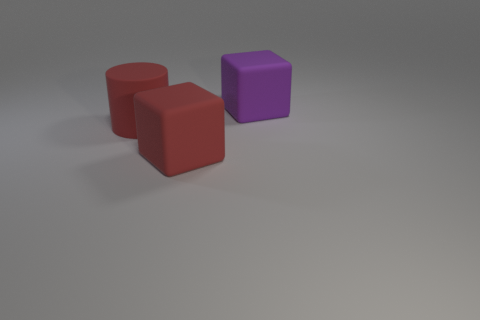Add 2 yellow cylinders. How many objects exist? 5 Subtract all blocks. How many objects are left? 1 Subtract 0 gray cylinders. How many objects are left? 3 Subtract all matte objects. Subtract all purple cylinders. How many objects are left? 0 Add 2 cubes. How many cubes are left? 4 Add 1 big things. How many big things exist? 4 